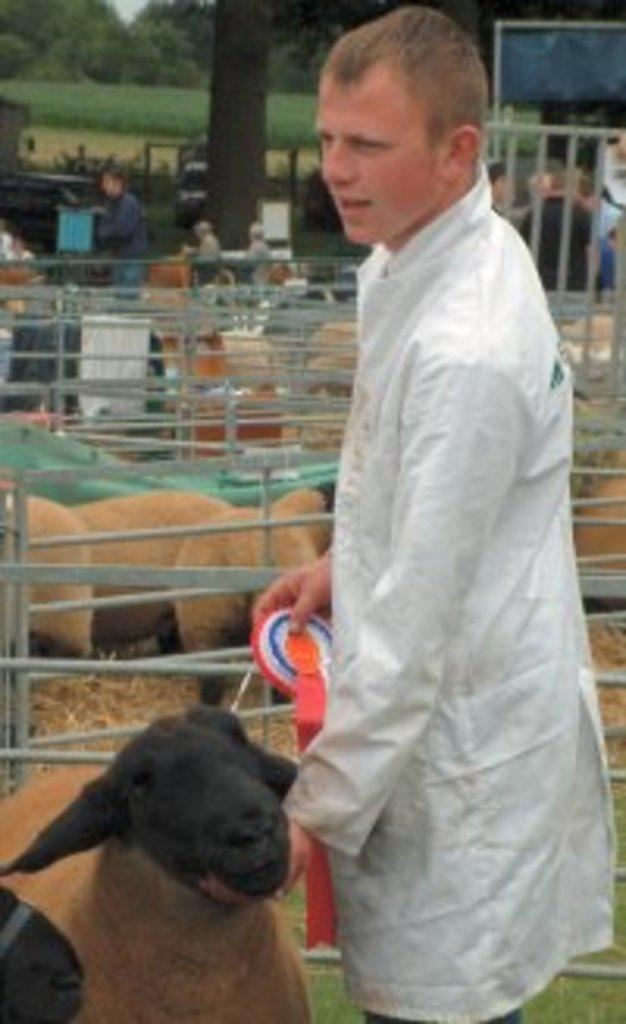In one or two sentences, can you explain what this image depicts? In this picture I can see a man on the right side, there are sheep and iron rods in the middle. In the background I can see few persons and trees. 